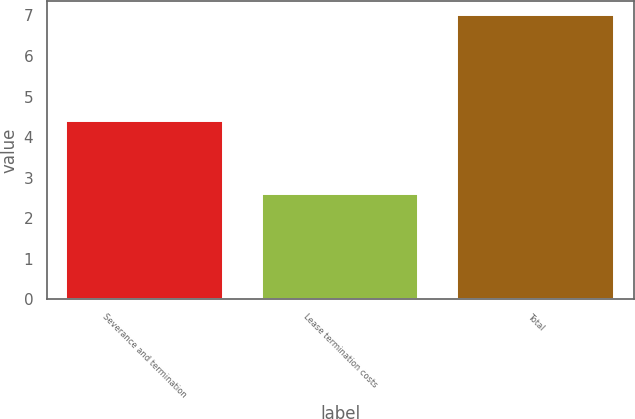Convert chart to OTSL. <chart><loc_0><loc_0><loc_500><loc_500><bar_chart><fcel>Severance and termination<fcel>Lease termination costs<fcel>Total<nl><fcel>4.4<fcel>2.6<fcel>7<nl></chart> 